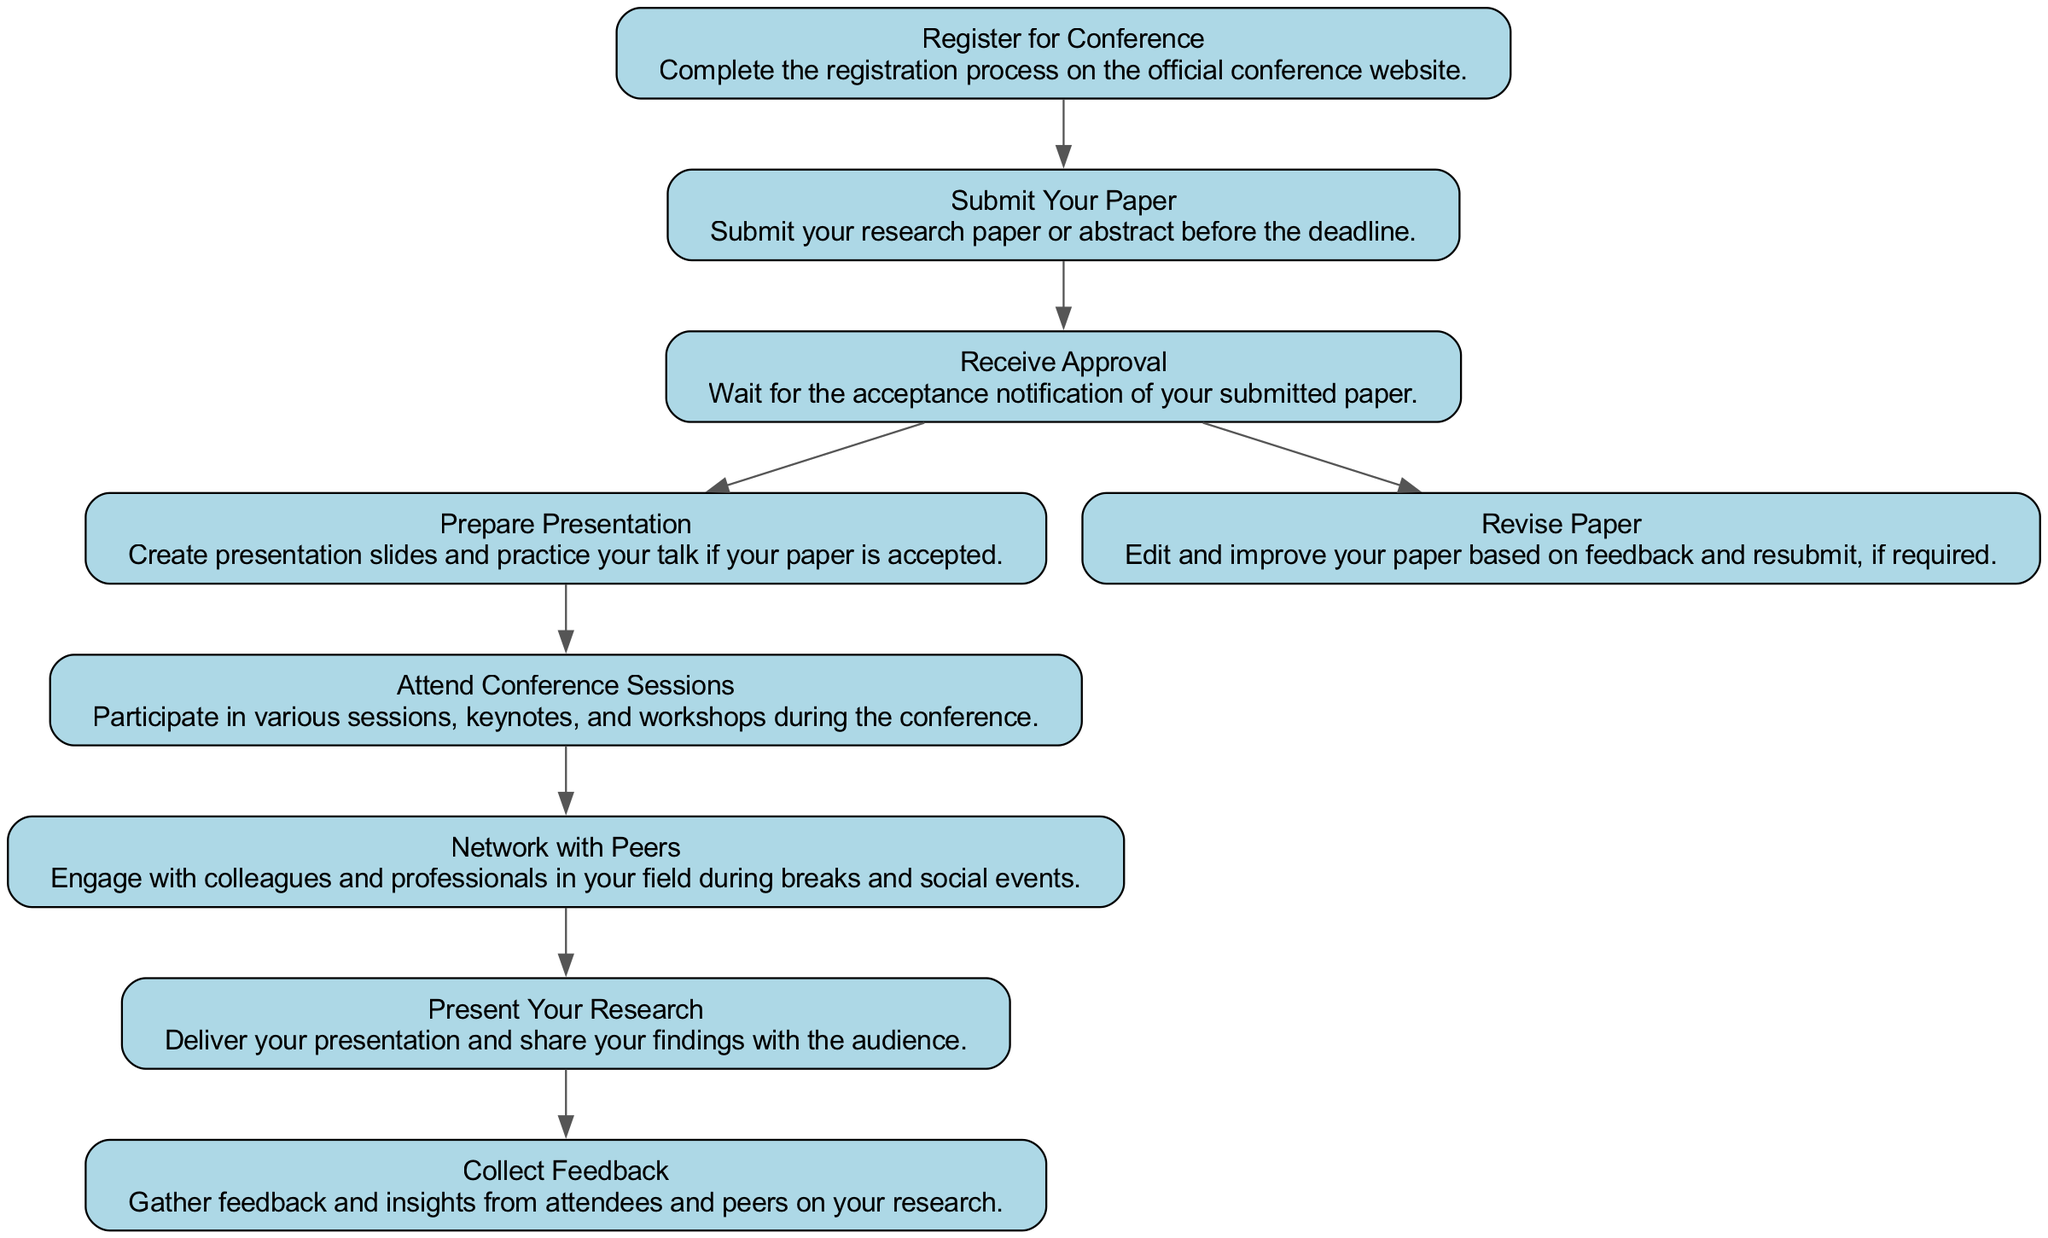What is the first step in attending an academic conference? The first step is found at the top of the flowchart and is "Register for Conference," which means completing the registration process on the official conference website.
Answer: Register for Conference How many main elements are in the process? By counting each item listed in the flowchart, we find a total of 9 main elements, each representing a distinct step in the process.
Answer: 9 What happens after you submit your paper? After submitting your paper, you wait for "Receive Approval," which is the next step indicated in the flowchart.
Answer: Receive Approval Which step follows "Prepare Presentation"? The step that follows "Prepare Presentation" is "Attend Conference Sessions," indicating that after preparing, you need to participate in the sessions of the conference.
Answer: Attend Conference Sessions Is there an option to revise the paper after submission? Yes, there is an option indicated by the flowchart that after receiving approval, if required, you may "Revise Paper," which means editing and improving your paper based on feedback.
Answer: Yes What activity occurs after presenting your research? The final activity after presenting your research, as shown in the flowchart, is "Collect Feedback," which involves gathering insights from attendees on the research presented.
Answer: Collect Feedback What are the last two steps in attending an academic conference? The last two steps as listed in the flowchart are "Present Your Research" followed by "Collect Feedback," which indicate the closing stages of participating in the conference.
Answer: Present Your Research, Collect Feedback Which step involves networking? The step that involves networking with peers during breaks and social events is "Network with Peers," indicating the importance of building connections at the conference.
Answer: Network with Peers What is the outcome if your paper is accepted? If your paper is accepted, the outcome is to "Prepare Presentation," meaning that you will need to create slides and practice your talk for the conference.
Answer: Prepare Presentation 